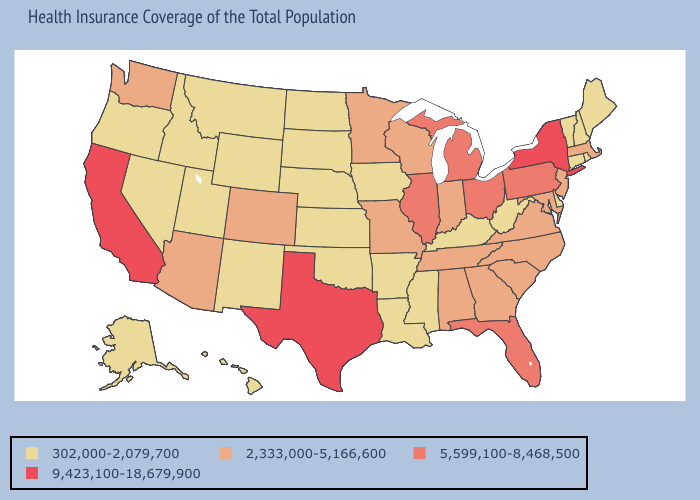What is the highest value in states that border Oregon?
Write a very short answer. 9,423,100-18,679,900. Name the states that have a value in the range 5,599,100-8,468,500?
Be succinct. Florida, Illinois, Michigan, Ohio, Pennsylvania. What is the value of New Hampshire?
Concise answer only. 302,000-2,079,700. Name the states that have a value in the range 9,423,100-18,679,900?
Be succinct. California, New York, Texas. What is the value of Maine?
Quick response, please. 302,000-2,079,700. Does Utah have the highest value in the USA?
Short answer required. No. How many symbols are there in the legend?
Be succinct. 4. What is the lowest value in the MidWest?
Write a very short answer. 302,000-2,079,700. Does California have the highest value in the USA?
Short answer required. Yes. Among the states that border Massachusetts , which have the lowest value?
Concise answer only. Connecticut, New Hampshire, Rhode Island, Vermont. What is the value of Virginia?
Write a very short answer. 2,333,000-5,166,600. Does New York have the highest value in the Northeast?
Quick response, please. Yes. Does New York have the highest value in the Northeast?
Give a very brief answer. Yes. What is the value of Maryland?
Write a very short answer. 2,333,000-5,166,600. What is the value of Idaho?
Be succinct. 302,000-2,079,700. 